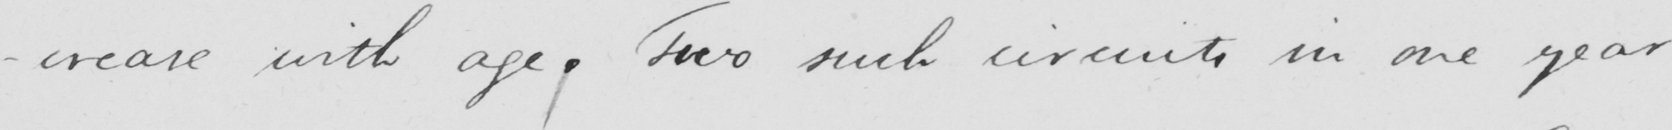What does this handwritten line say? -crease with age . Two such circuits in one year 